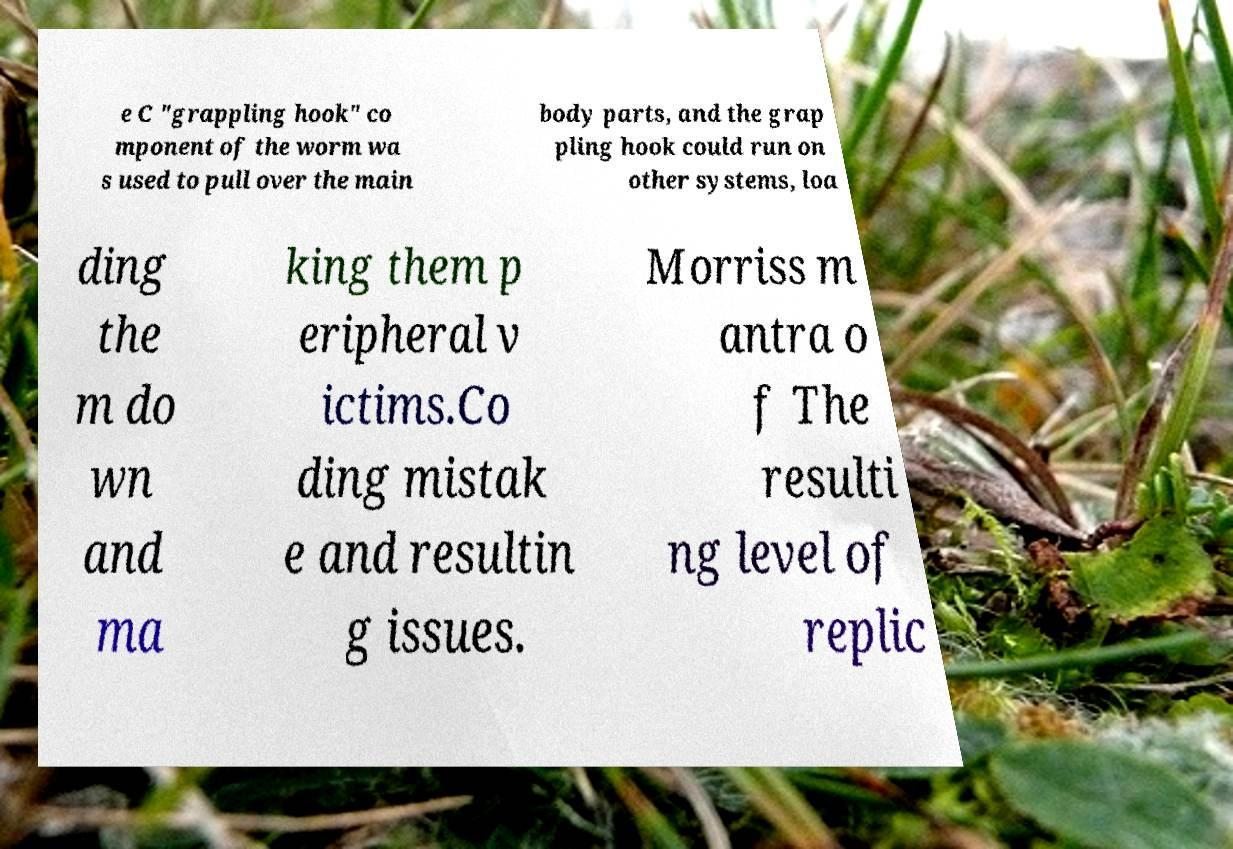For documentation purposes, I need the text within this image transcribed. Could you provide that? e C "grappling hook" co mponent of the worm wa s used to pull over the main body parts, and the grap pling hook could run on other systems, loa ding the m do wn and ma king them p eripheral v ictims.Co ding mistak e and resultin g issues. Morriss m antra o f The resulti ng level of replic 